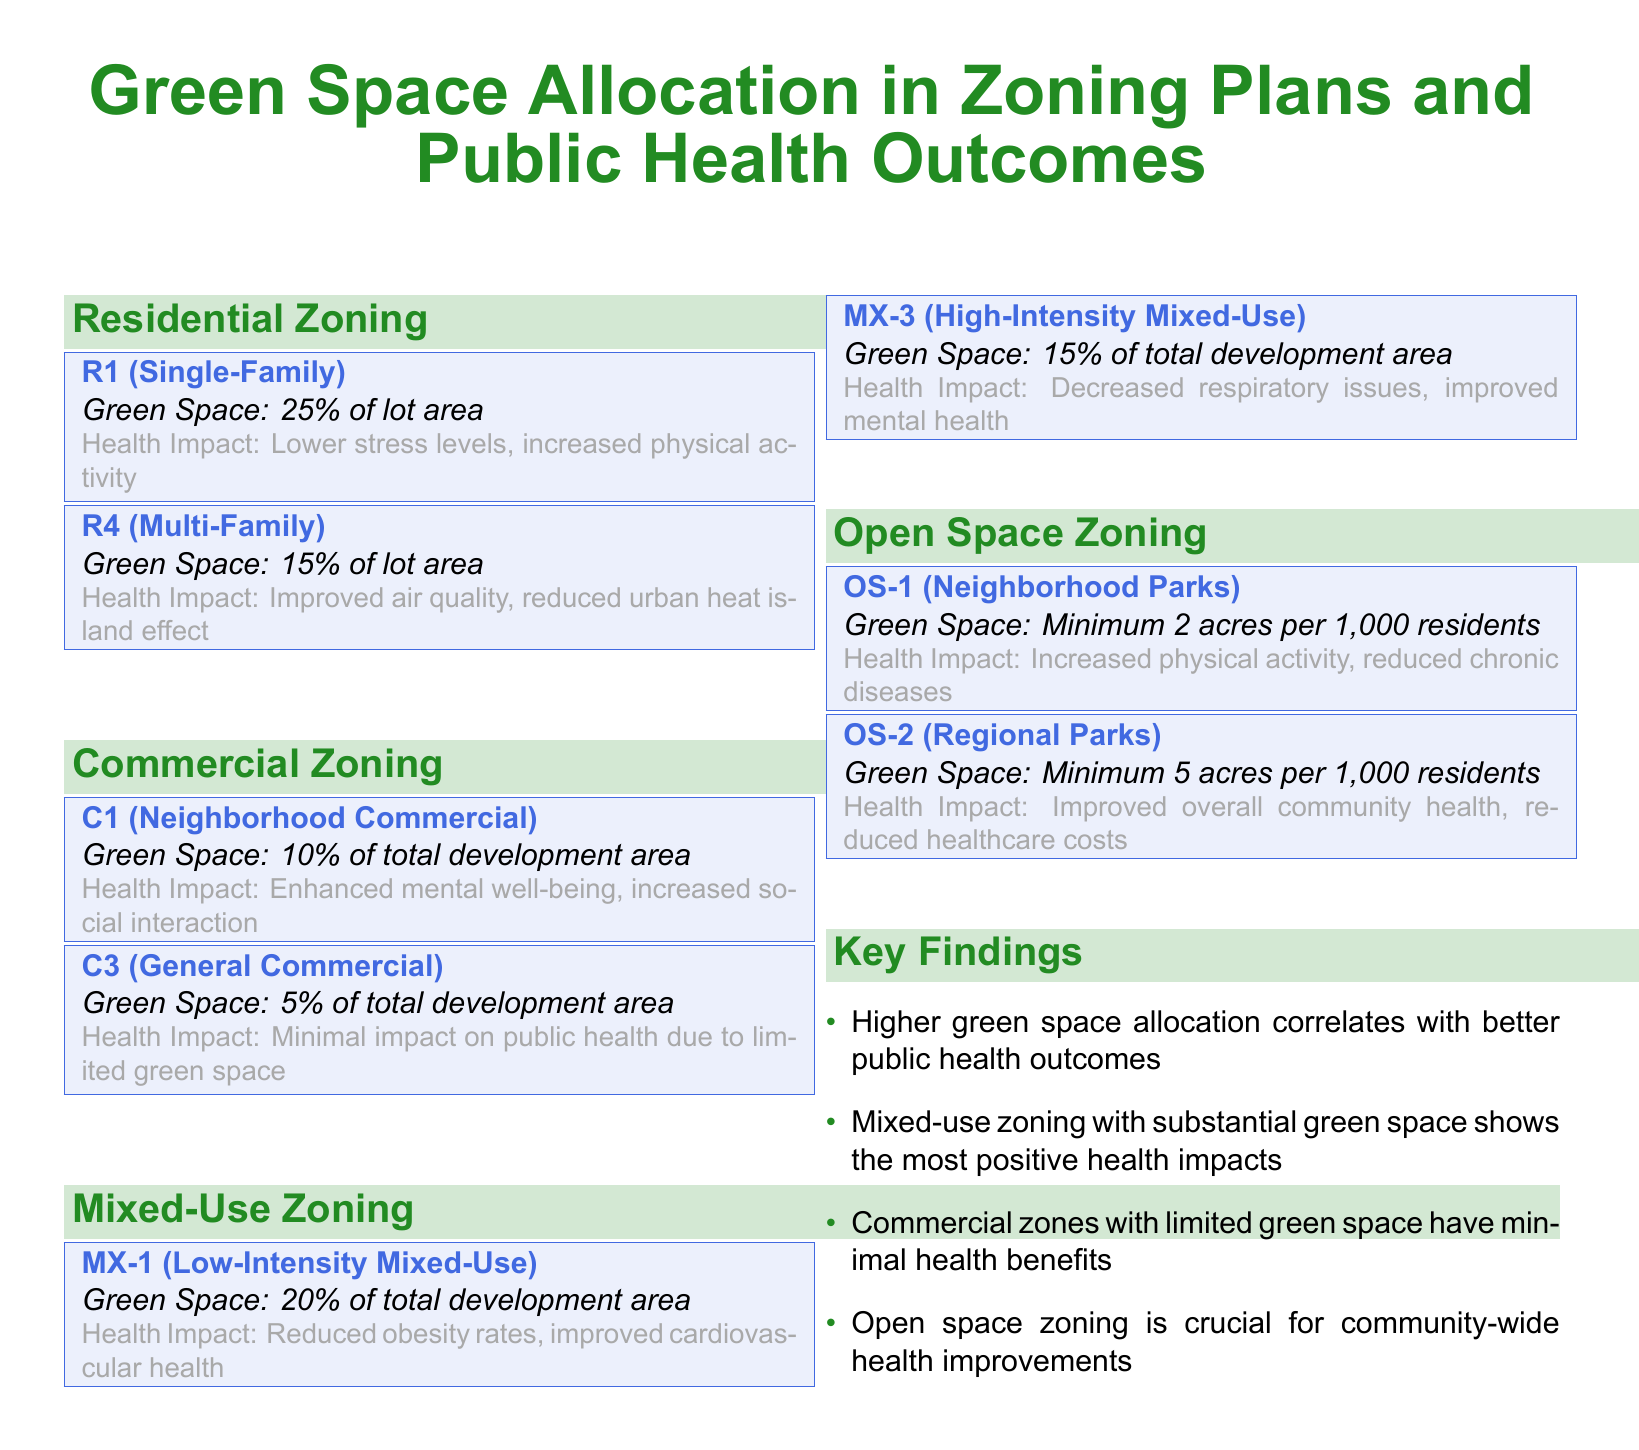What percentage of lot area do R1 zones allocate for green space? The R1 (Single-Family) zoning plan allocates 25% of the lot area for green space.
Answer: 25% What health impact is associated with C3 (General Commercial) zoning? The C3 (General Commercial) zoning has a minimal impact on public health due to limited green space.
Answer: Minimal impact What is the minimum green space requirement for OS-2 (Regional Parks)? The minimum green space requirement for OS-2 is 5 acres per 1,000 residents.
Answer: 5 acres Which zoning type has the highest percentage of green space allocation? R1 (Single-Family) zoning has the highest percentage of green space allocation at 25%.
Answer: R1 (Single-Family) Which zoning category is linked to improved cardiovascular health? MX-1 (Low-Intensity Mixed-Use) zoning is linked to reduced obesity rates and improved cardiovascular health.
Answer: MX-1 What is the key finding regarding mixed-use zoning? Mixed-use zoning with substantial green space shows the most positive health impacts.
Answer: Most positive health impacts How many acres of green space is required per 1,000 residents in OS-1? OS-1 (Neighborhood Parks) requires a minimum of 2 acres per 1,000 residents.
Answer: 2 acres What is the health impact associated with open space zoning? Open space zoning is crucial for community-wide health improvements.
Answer: Crucial for health improvements 